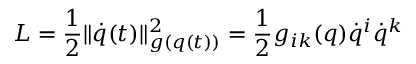<formula> <loc_0><loc_0><loc_500><loc_500>L = \frac { 1 } { 2 } \| \dot { q } ( t ) \| _ { g ( q ( t ) ) } ^ { 2 } = \frac { 1 } { 2 } g _ { i k } ( q ) \dot { q } ^ { i } \dot { q } ^ { k }</formula> 